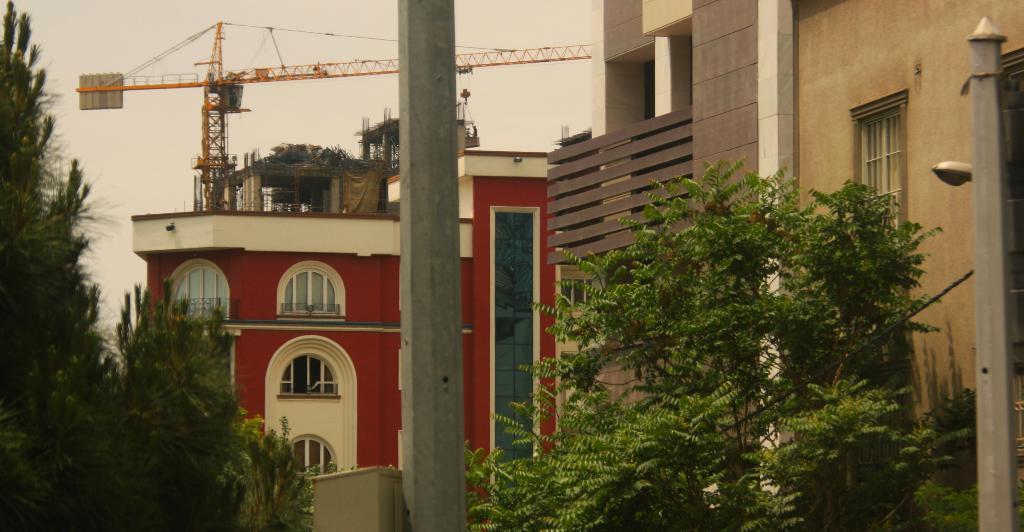How would you summarize this image in a sentence or two? In this image I can see few trees in the front. In the background I can see few buildings and on the right side of this image I can see a light. I can also see a crane on the top side of this image. 